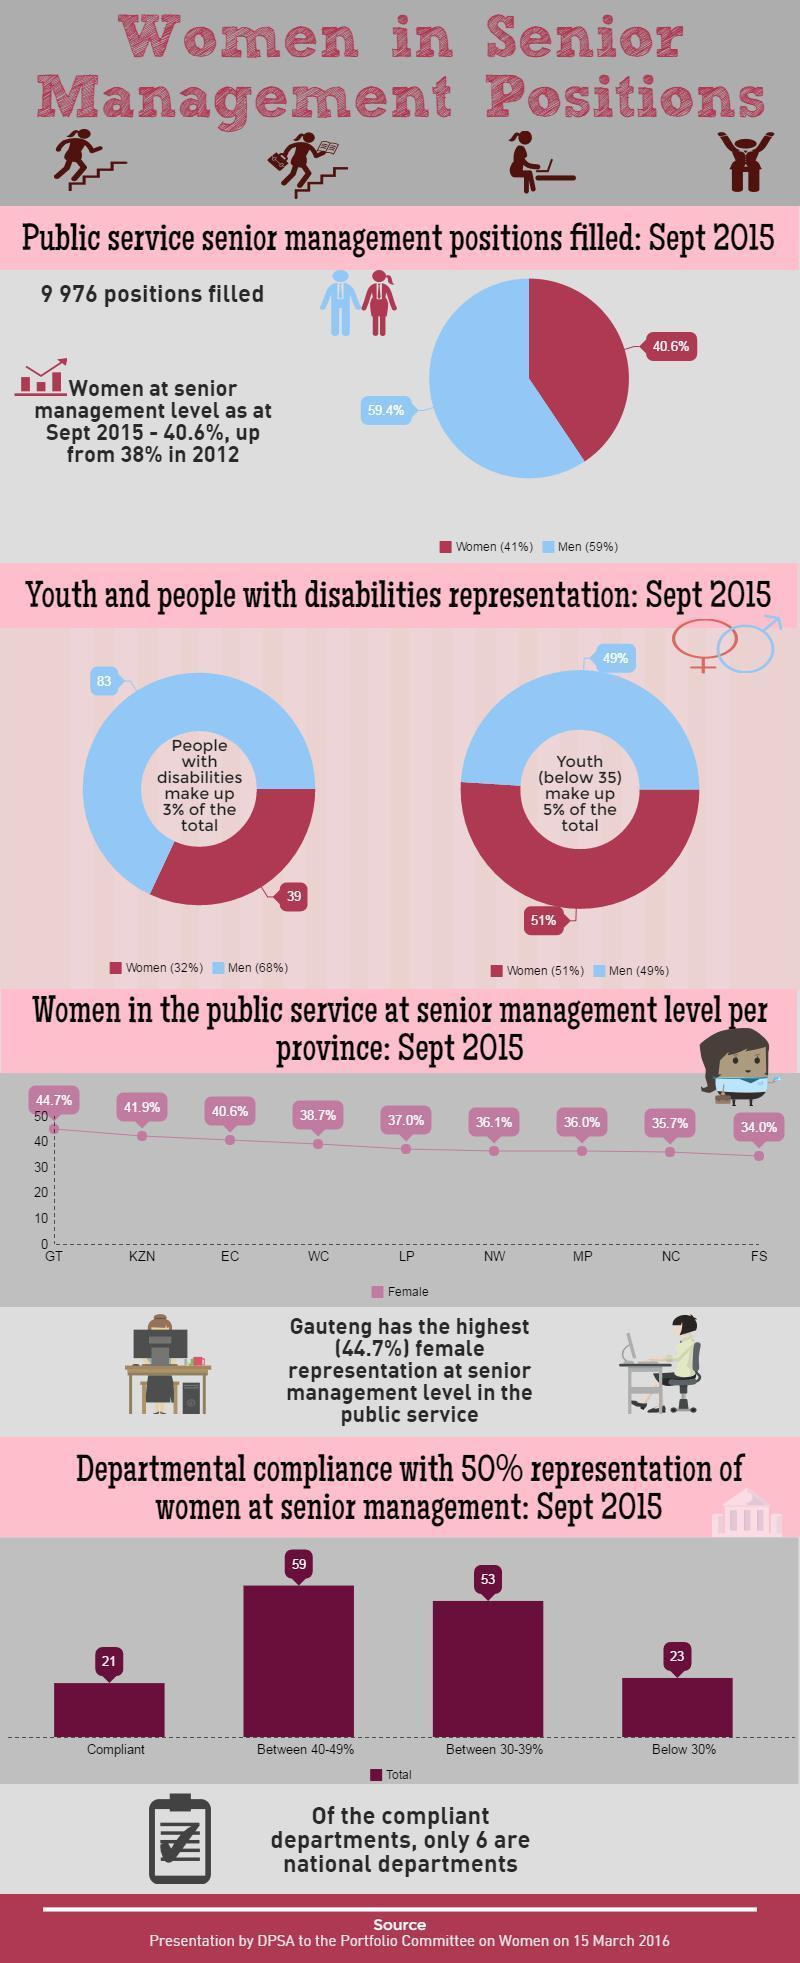What percent of females occupied public service senior management positions in Sept 2015 as per the pie chart?
Answer the question with a short phrase. 40.6% By what percent did women at senior management level rise from 2012 to 2014? 2.6% 